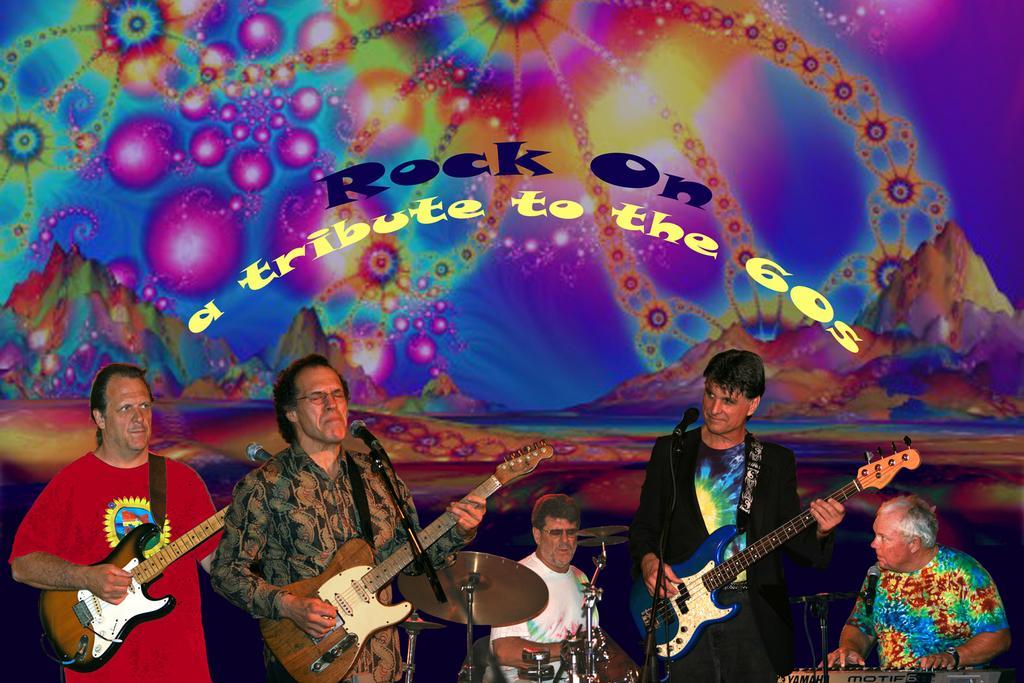Please provide a concise description of this image. In this picture we can see some people are standing and playing a musical instruments and it is a animated picture. 